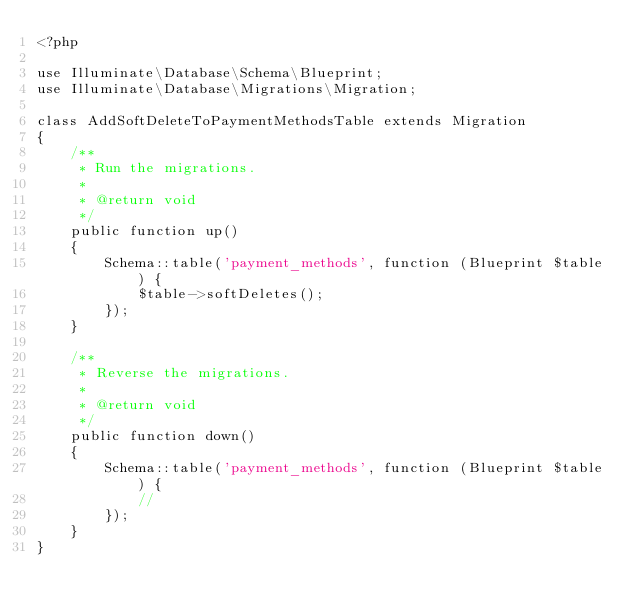<code> <loc_0><loc_0><loc_500><loc_500><_PHP_><?php

use Illuminate\Database\Schema\Blueprint;
use Illuminate\Database\Migrations\Migration;

class AddSoftDeleteToPaymentMethodsTable extends Migration
{
    /**
     * Run the migrations.
     *
     * @return void
     */
    public function up()
    {
        Schema::table('payment_methods', function (Blueprint $table) {
            $table->softDeletes();
        });
    }

    /**
     * Reverse the migrations.
     *
     * @return void
     */
    public function down()
    {
        Schema::table('payment_methods', function (Blueprint $table) {
            //
        });
    }
}
</code> 